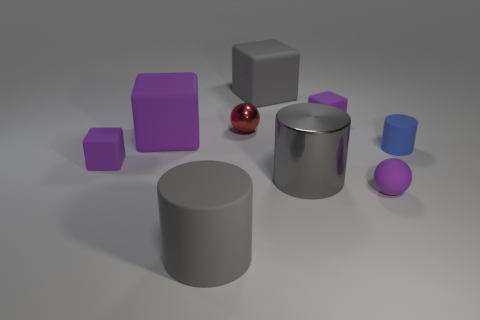There is a big block that is the same color as the shiny cylinder; what material is it?
Keep it short and to the point. Rubber. There is a large gray object behind the red thing; is its shape the same as the big purple matte thing?
Offer a terse response. Yes. How many gray rubber cylinders have the same size as the gray metal object?
Keep it short and to the point. 1. There is a rubber sphere that is to the right of the red ball; how many tiny cubes are behind it?
Your response must be concise. 2. Are the large gray block that is behind the gray rubber cylinder and the blue thing made of the same material?
Offer a terse response. Yes. Is the material of the purple thing that is behind the tiny red thing the same as the small ball left of the gray metallic cylinder?
Ensure brevity in your answer.  No. Is the number of tiny red metallic spheres that are in front of the tiny red metal thing greater than the number of tiny purple spheres?
Give a very brief answer. No. There is a large cylinder that is behind the tiny purple thing in front of the large gray metallic cylinder; what is its color?
Keep it short and to the point. Gray. The red metal object that is the same size as the blue rubber object is what shape?
Offer a terse response. Sphere. What shape is the big rubber thing that is the same color as the tiny rubber sphere?
Ensure brevity in your answer.  Cube. 